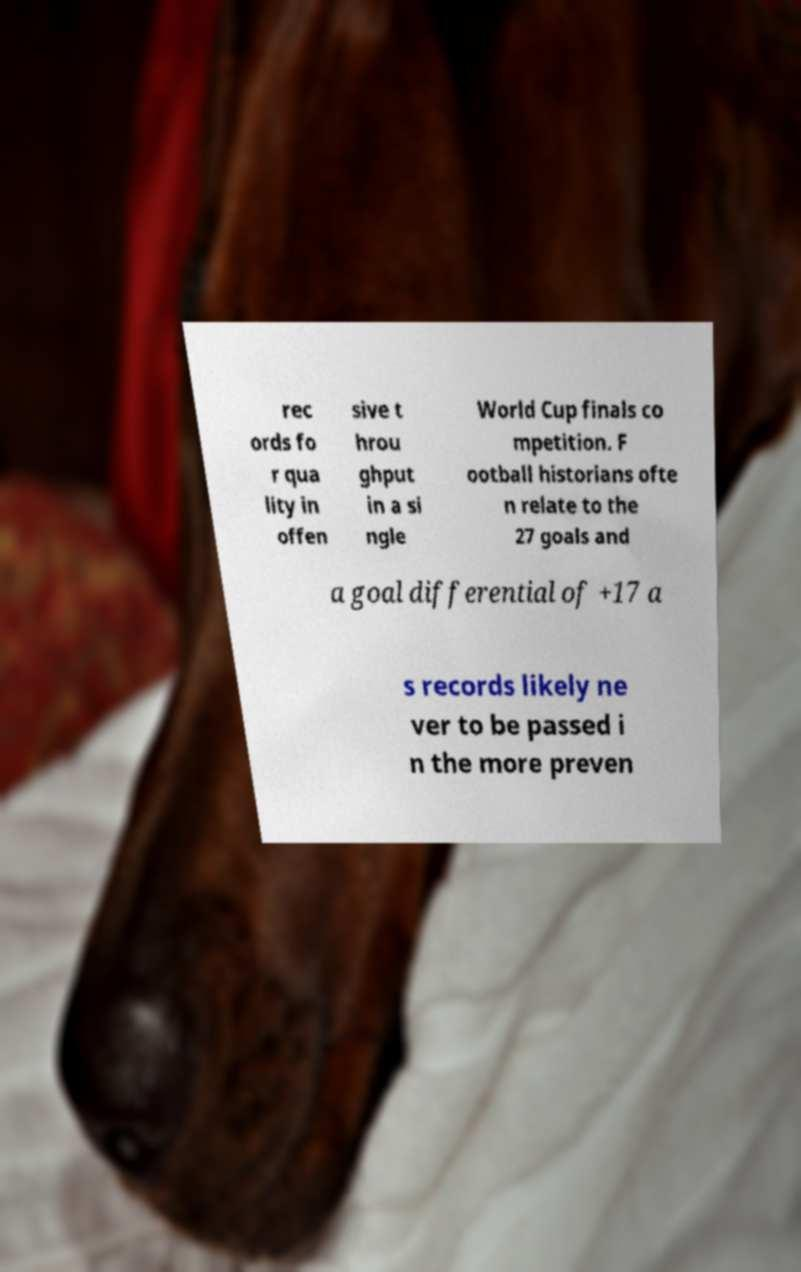Please identify and transcribe the text found in this image. rec ords fo r qua lity in offen sive t hrou ghput in a si ngle World Cup finals co mpetition. F ootball historians ofte n relate to the 27 goals and a goal differential of +17 a s records likely ne ver to be passed i n the more preven 